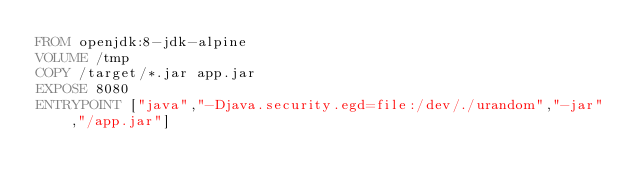<code> <loc_0><loc_0><loc_500><loc_500><_Dockerfile_>FROM openjdk:8-jdk-alpine
VOLUME /tmp
COPY /target/*.jar app.jar
EXPOSE 8080
ENTRYPOINT ["java","-Djava.security.egd=file:/dev/./urandom","-jar","/app.jar"]</code> 